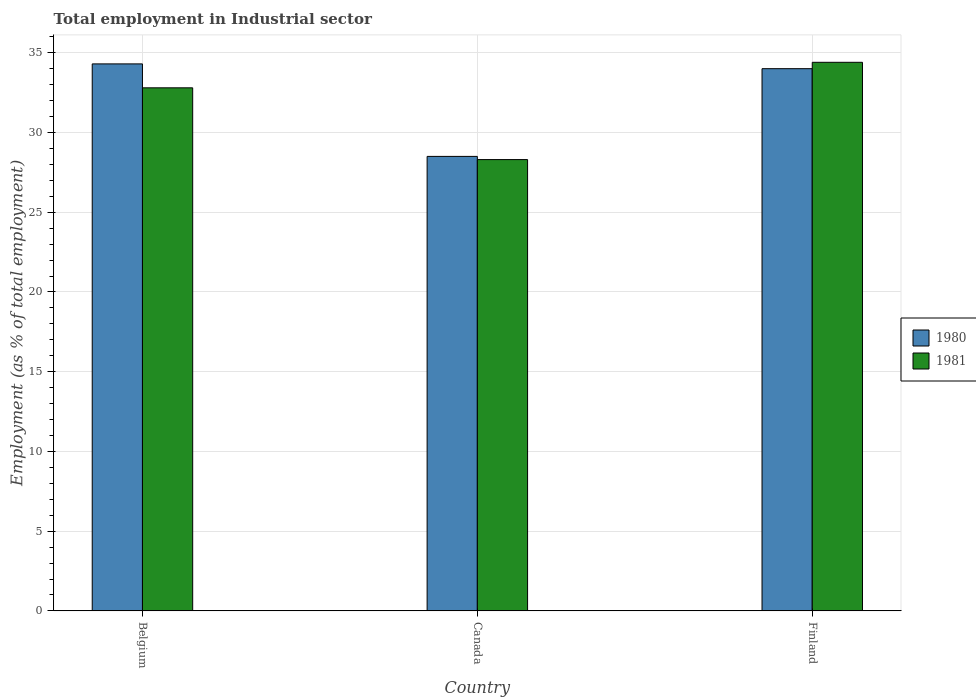How many groups of bars are there?
Ensure brevity in your answer.  3. How many bars are there on the 3rd tick from the right?
Your answer should be compact. 2. What is the label of the 3rd group of bars from the left?
Your answer should be very brief. Finland. In how many cases, is the number of bars for a given country not equal to the number of legend labels?
Offer a very short reply. 0. What is the employment in industrial sector in 1981 in Canada?
Offer a terse response. 28.3. Across all countries, what is the maximum employment in industrial sector in 1980?
Make the answer very short. 34.3. Across all countries, what is the minimum employment in industrial sector in 1980?
Provide a short and direct response. 28.5. In which country was the employment in industrial sector in 1980 minimum?
Give a very brief answer. Canada. What is the total employment in industrial sector in 1981 in the graph?
Offer a very short reply. 95.5. What is the difference between the employment in industrial sector in 1980 in Canada and that in Finland?
Offer a terse response. -5.5. What is the difference between the employment in industrial sector in 1981 in Canada and the employment in industrial sector in 1980 in Belgium?
Keep it short and to the point. -6. What is the average employment in industrial sector in 1980 per country?
Offer a terse response. 32.27. What is the difference between the employment in industrial sector of/in 1980 and employment in industrial sector of/in 1981 in Canada?
Give a very brief answer. 0.2. In how many countries, is the employment in industrial sector in 1980 greater than 30 %?
Your response must be concise. 2. What is the ratio of the employment in industrial sector in 1980 in Belgium to that in Canada?
Offer a very short reply. 1.2. Is the difference between the employment in industrial sector in 1980 in Belgium and Finland greater than the difference between the employment in industrial sector in 1981 in Belgium and Finland?
Provide a succinct answer. Yes. What is the difference between the highest and the second highest employment in industrial sector in 1981?
Give a very brief answer. -1.6. What is the difference between the highest and the lowest employment in industrial sector in 1981?
Give a very brief answer. 6.1. Is the sum of the employment in industrial sector in 1981 in Canada and Finland greater than the maximum employment in industrial sector in 1980 across all countries?
Provide a succinct answer. Yes. What is the difference between two consecutive major ticks on the Y-axis?
Offer a very short reply. 5. Are the values on the major ticks of Y-axis written in scientific E-notation?
Offer a terse response. No. Does the graph contain any zero values?
Offer a very short reply. No. Does the graph contain grids?
Your answer should be very brief. Yes. Where does the legend appear in the graph?
Give a very brief answer. Center right. How are the legend labels stacked?
Offer a terse response. Vertical. What is the title of the graph?
Give a very brief answer. Total employment in Industrial sector. What is the label or title of the X-axis?
Provide a short and direct response. Country. What is the label or title of the Y-axis?
Ensure brevity in your answer.  Employment (as % of total employment). What is the Employment (as % of total employment) in 1980 in Belgium?
Your response must be concise. 34.3. What is the Employment (as % of total employment) in 1981 in Belgium?
Make the answer very short. 32.8. What is the Employment (as % of total employment) in 1981 in Canada?
Provide a succinct answer. 28.3. What is the Employment (as % of total employment) in 1980 in Finland?
Your answer should be compact. 34. What is the Employment (as % of total employment) of 1981 in Finland?
Give a very brief answer. 34.4. Across all countries, what is the maximum Employment (as % of total employment) of 1980?
Provide a succinct answer. 34.3. Across all countries, what is the maximum Employment (as % of total employment) in 1981?
Offer a terse response. 34.4. Across all countries, what is the minimum Employment (as % of total employment) of 1981?
Your response must be concise. 28.3. What is the total Employment (as % of total employment) of 1980 in the graph?
Your answer should be very brief. 96.8. What is the total Employment (as % of total employment) in 1981 in the graph?
Provide a succinct answer. 95.5. What is the difference between the Employment (as % of total employment) in 1980 in Belgium and that in Finland?
Keep it short and to the point. 0.3. What is the difference between the Employment (as % of total employment) of 1981 in Belgium and that in Finland?
Give a very brief answer. -1.6. What is the difference between the Employment (as % of total employment) of 1981 in Canada and that in Finland?
Provide a succinct answer. -6.1. What is the difference between the Employment (as % of total employment) of 1980 in Canada and the Employment (as % of total employment) of 1981 in Finland?
Your response must be concise. -5.9. What is the average Employment (as % of total employment) in 1980 per country?
Give a very brief answer. 32.27. What is the average Employment (as % of total employment) of 1981 per country?
Your answer should be compact. 31.83. What is the difference between the Employment (as % of total employment) of 1980 and Employment (as % of total employment) of 1981 in Belgium?
Provide a short and direct response. 1.5. What is the difference between the Employment (as % of total employment) of 1980 and Employment (as % of total employment) of 1981 in Canada?
Your answer should be compact. 0.2. What is the difference between the Employment (as % of total employment) in 1980 and Employment (as % of total employment) in 1981 in Finland?
Provide a short and direct response. -0.4. What is the ratio of the Employment (as % of total employment) in 1980 in Belgium to that in Canada?
Make the answer very short. 1.2. What is the ratio of the Employment (as % of total employment) in 1981 in Belgium to that in Canada?
Your answer should be very brief. 1.16. What is the ratio of the Employment (as % of total employment) in 1980 in Belgium to that in Finland?
Offer a very short reply. 1.01. What is the ratio of the Employment (as % of total employment) in 1981 in Belgium to that in Finland?
Ensure brevity in your answer.  0.95. What is the ratio of the Employment (as % of total employment) in 1980 in Canada to that in Finland?
Your answer should be compact. 0.84. What is the ratio of the Employment (as % of total employment) of 1981 in Canada to that in Finland?
Offer a terse response. 0.82. What is the difference between the highest and the second highest Employment (as % of total employment) in 1980?
Offer a very short reply. 0.3. What is the difference between the highest and the lowest Employment (as % of total employment) of 1980?
Ensure brevity in your answer.  5.8. What is the difference between the highest and the lowest Employment (as % of total employment) in 1981?
Keep it short and to the point. 6.1. 